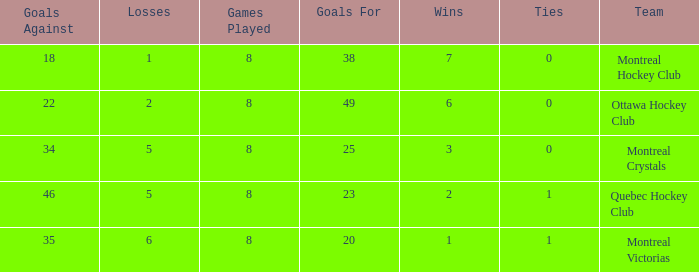What is the total number of goals for when the ties is more than 0, the goals against is more than 35 and the wins is less than 2? 0.0. 